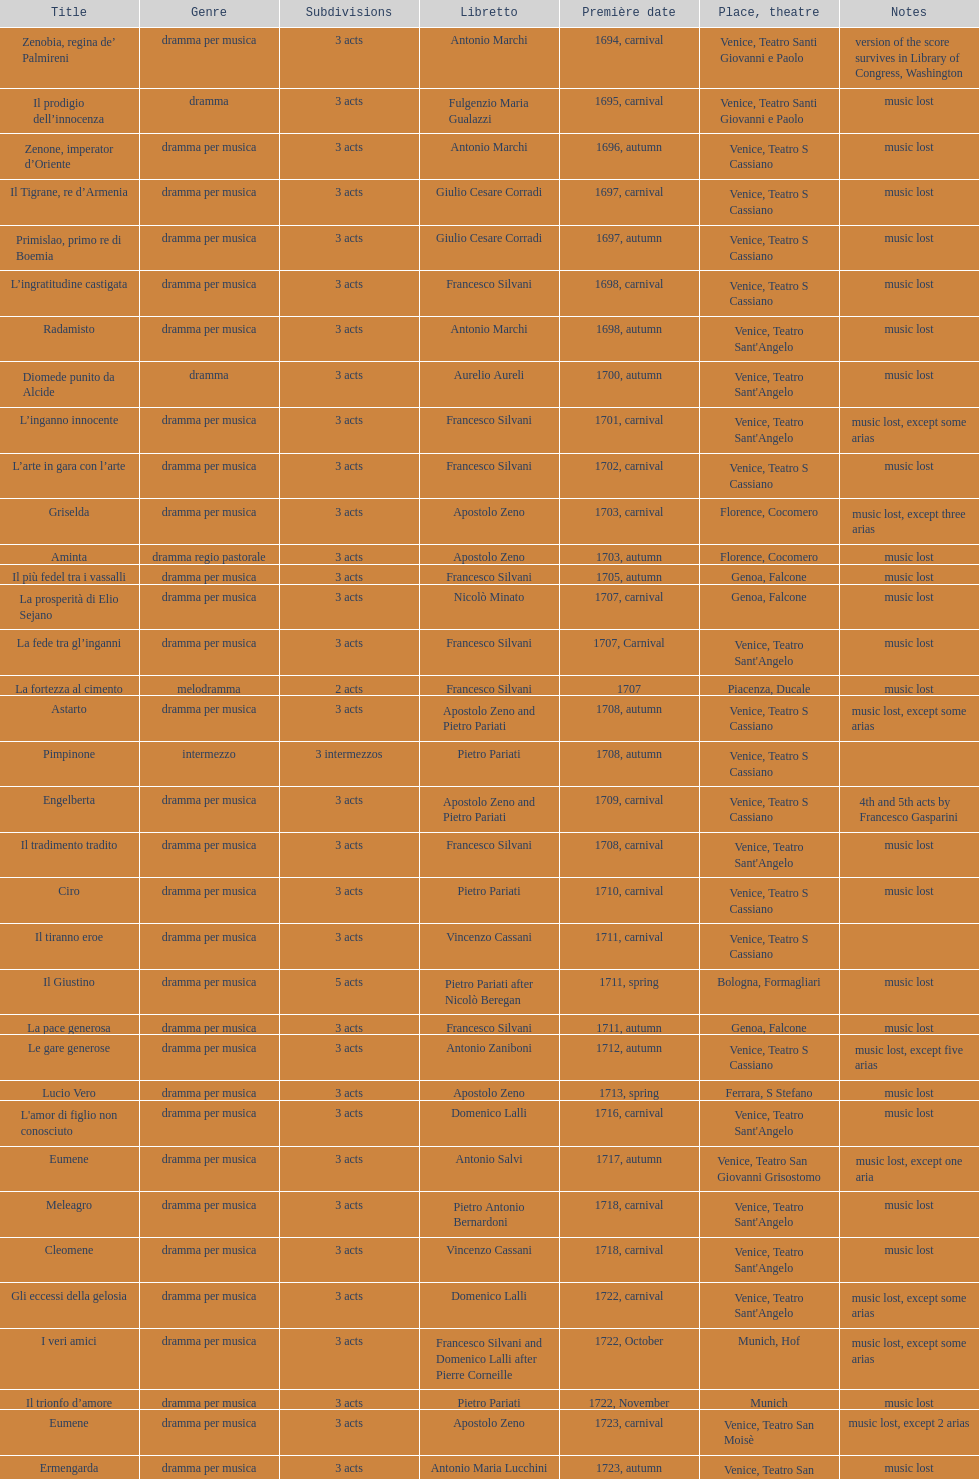What quantity of acts does il giustino consist of? 5. 